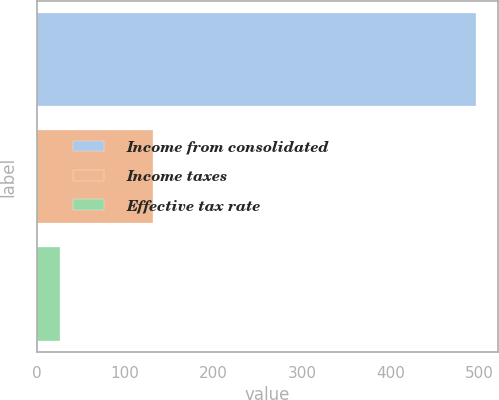Convert chart to OTSL. <chart><loc_0><loc_0><loc_500><loc_500><bar_chart><fcel>Income from consolidated<fcel>Income taxes<fcel>Effective tax rate<nl><fcel>496.2<fcel>131.3<fcel>26.5<nl></chart> 